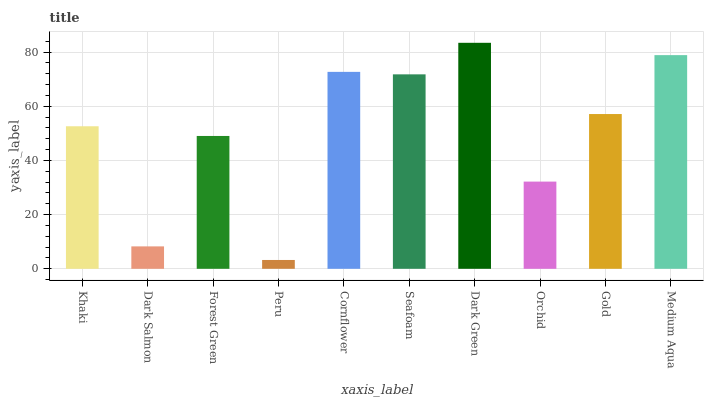Is Peru the minimum?
Answer yes or no. Yes. Is Dark Green the maximum?
Answer yes or no. Yes. Is Dark Salmon the minimum?
Answer yes or no. No. Is Dark Salmon the maximum?
Answer yes or no. No. Is Khaki greater than Dark Salmon?
Answer yes or no. Yes. Is Dark Salmon less than Khaki?
Answer yes or no. Yes. Is Dark Salmon greater than Khaki?
Answer yes or no. No. Is Khaki less than Dark Salmon?
Answer yes or no. No. Is Gold the high median?
Answer yes or no. Yes. Is Khaki the low median?
Answer yes or no. Yes. Is Orchid the high median?
Answer yes or no. No. Is Forest Green the low median?
Answer yes or no. No. 